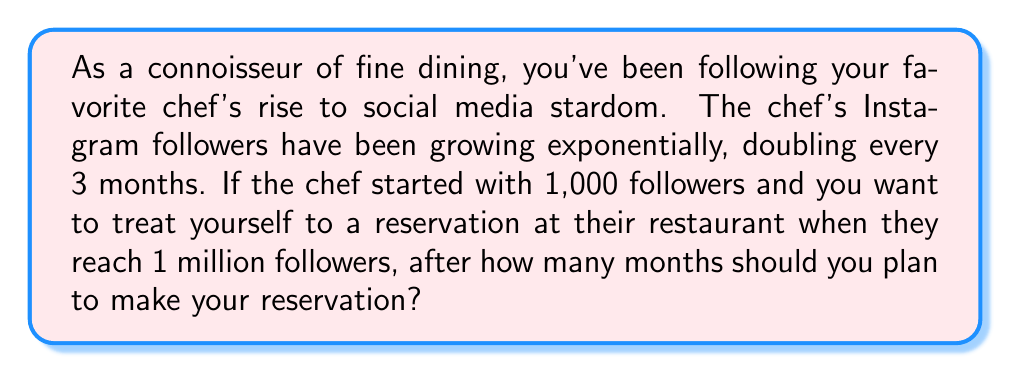Can you answer this question? Let's approach this step-by-step:

1) We start with an initial value of 1,000 followers and need to reach 1,000,000 followers.

2) The number of followers doubles every 3 months. This means we can express the number of followers after $n$ 3-month periods as:

   $$a_n = 1000 \cdot 2^n$$

3) We need to find $n$ when $a_n = 1,000,000$:

   $$1,000,000 = 1000 \cdot 2^n$$

4) Dividing both sides by 1000:

   $$1,000 = 2^n$$

5) Taking the logarithm (base 2) of both sides:

   $$\log_2(1000) = n$$

6) Using the change of base formula:

   $$n = \frac{\log(1000)}{\log(2)} \approx 9.97$$

7) This means it will take 10 3-month periods to reach 1 million followers.

8) To convert to months, we multiply by 3:

   $$10 \cdot 3 = 30\text{ months}$$

Therefore, you should plan to make your reservation after 30 months.
Answer: 30 months 